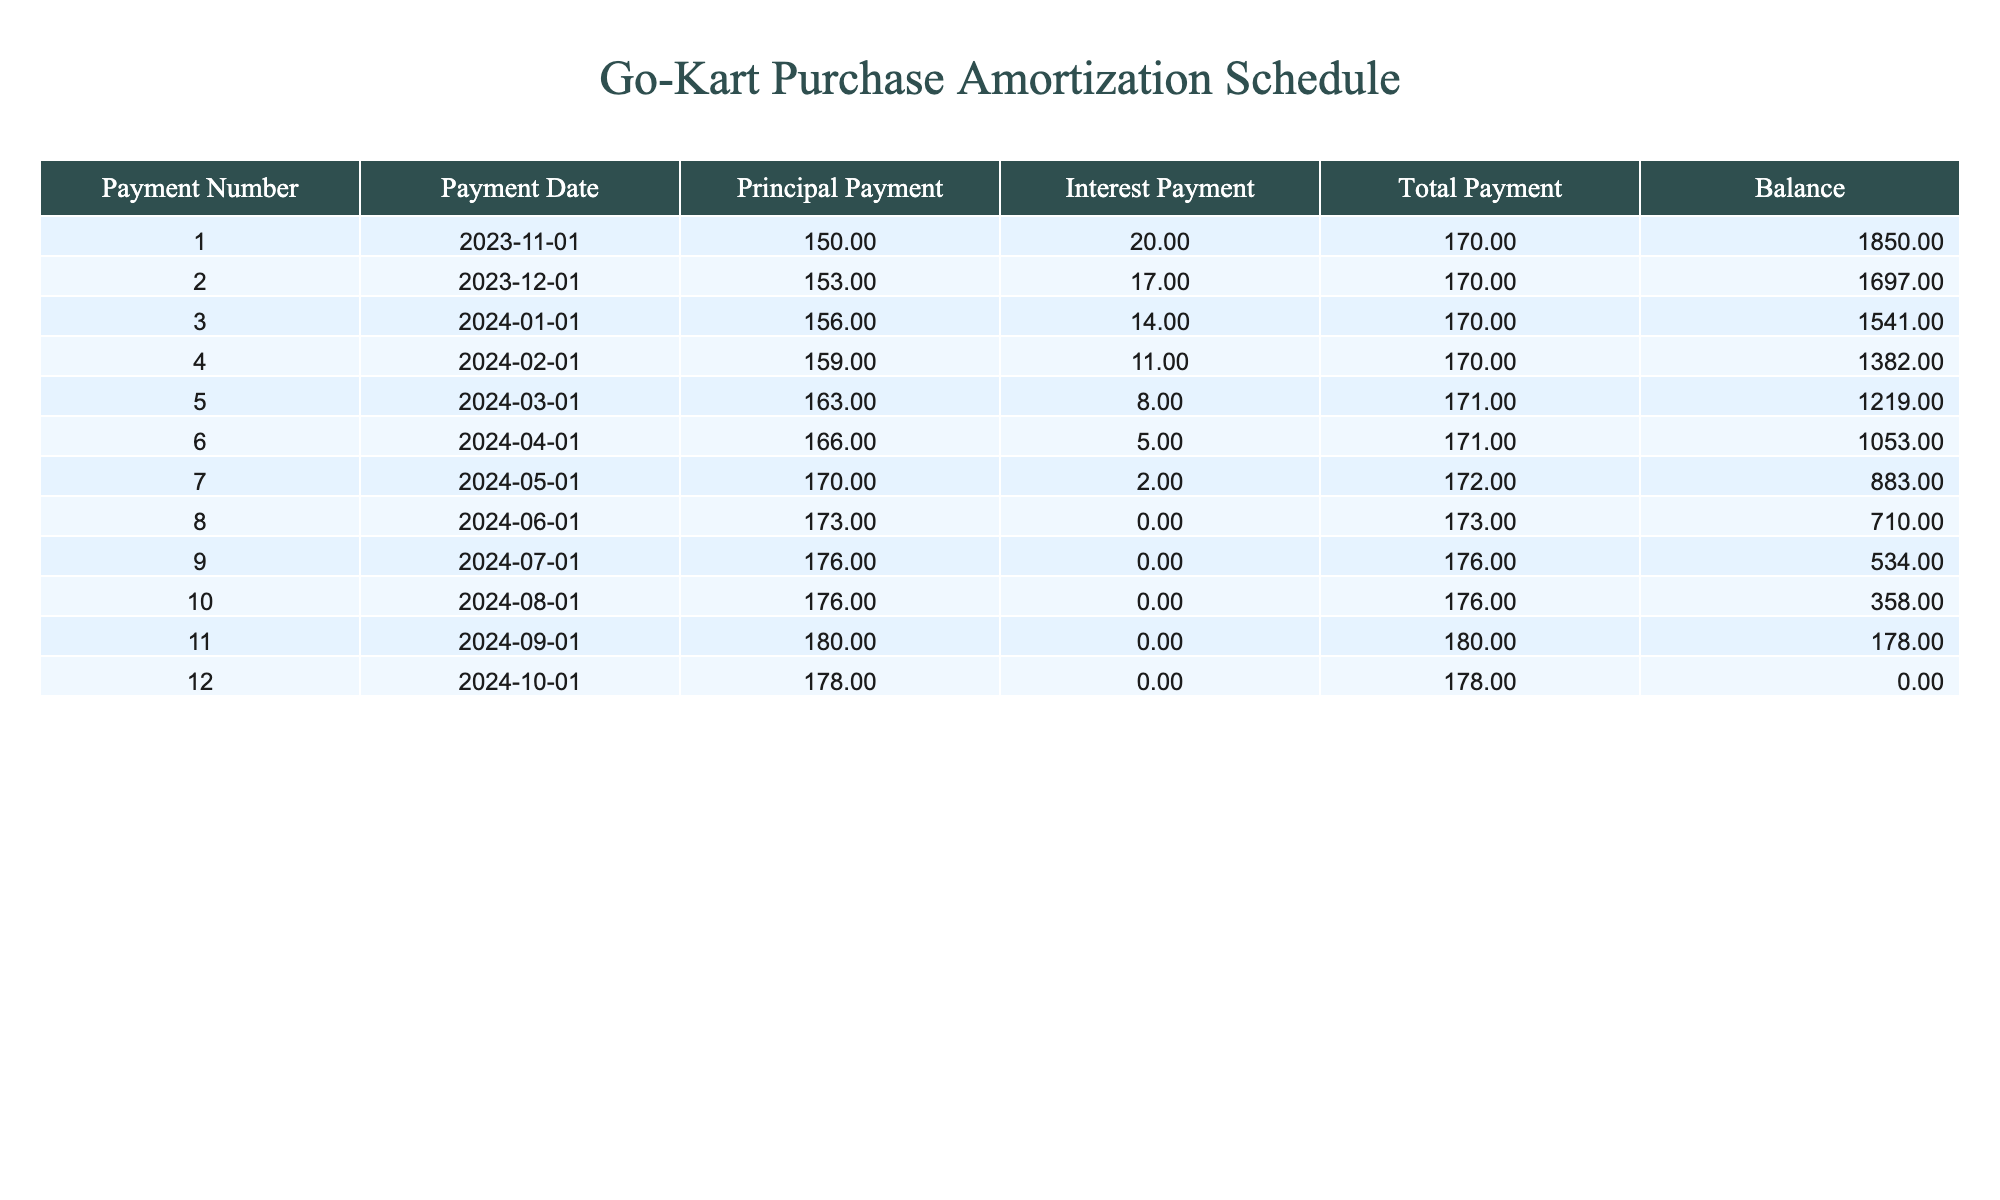What is the total payment for the first month? The total payment in the first month is found in the "Total Payment" column for Payment Number 1. According to the table, it is 170.00.
Answer: 170.00 What was the principal payment made in the last month? The principal payment for the last month can be found in the "Principal Payment" column for Payment Number 12. The amount is 178.00.
Answer: 178.00 What is the balance after the fifth payment? To find the balance after the fifth payment, we look at the "Balance" column for Payment Number 5, which shows 1219.00.
Answer: 1219.00 Is the interest payment ever zero? By examining the "Interest Payment" column, we see that during the eighth payment and onward (from Payment Number 8 and 9), the interest payment is indeed zero.
Answer: Yes What is the average total payment made over the entire period? First, we sum up all total payments: (170 + 170 + 170 + 170 + 171 + 171 + 172 + 173 + 176 + 176 + 180 + 178) = 2,077. Since there are 12 payments, we divide by 12, which gives us 2077 / 12 = 173.08.
Answer: 173.08 What is the difference between the first and last principal payments? The first principal payment is 150.00, and the last principal payment is 178.00. To find the difference, we subtract the first from the last: 178.00 - 150.00 = 28.00.
Answer: 28.00 How much was the interest payment in the 9th month? We check the "Interest Payment" column for Payment Number 9, which shows that the interest payment was 0.00.
Answer: 0.00 What is the maximum balance after any payment? By reviewing the "Balance" column, the highest balance recorded is 1850.00, which occurred right after the first payment.
Answer: 1850.00 How many payments had a principal payment that was less than 160? By checking the "Principal Payment" column for each payment, we find that the first four payments (150.00, 153.00, 156.00, and 159.00) are all less than 160. Therefore, there are four such payments.
Answer: 4 